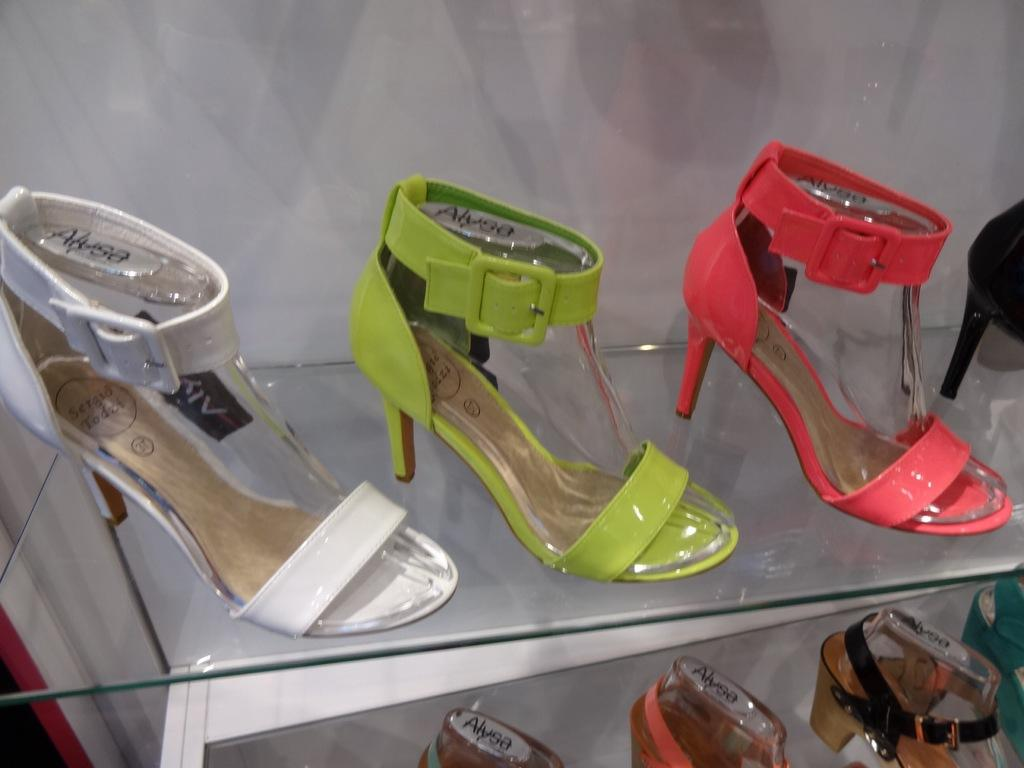What is placed on the glass in the image? There are footwear on the glass in the image. What colors can be seen on the footwear? The footwear colors include off-white, green, pink, black, and brown. Are there any words written on the footwear? Yes, there are words written on the footwear. What can be seen in the background of the image? There is a white wall visible in the image. How much money is hidden inside the footwear in the image? There is no money present in the image; it features footwear with words written on them. Are there any dogs visible in the image? There are no dogs present in the image. 